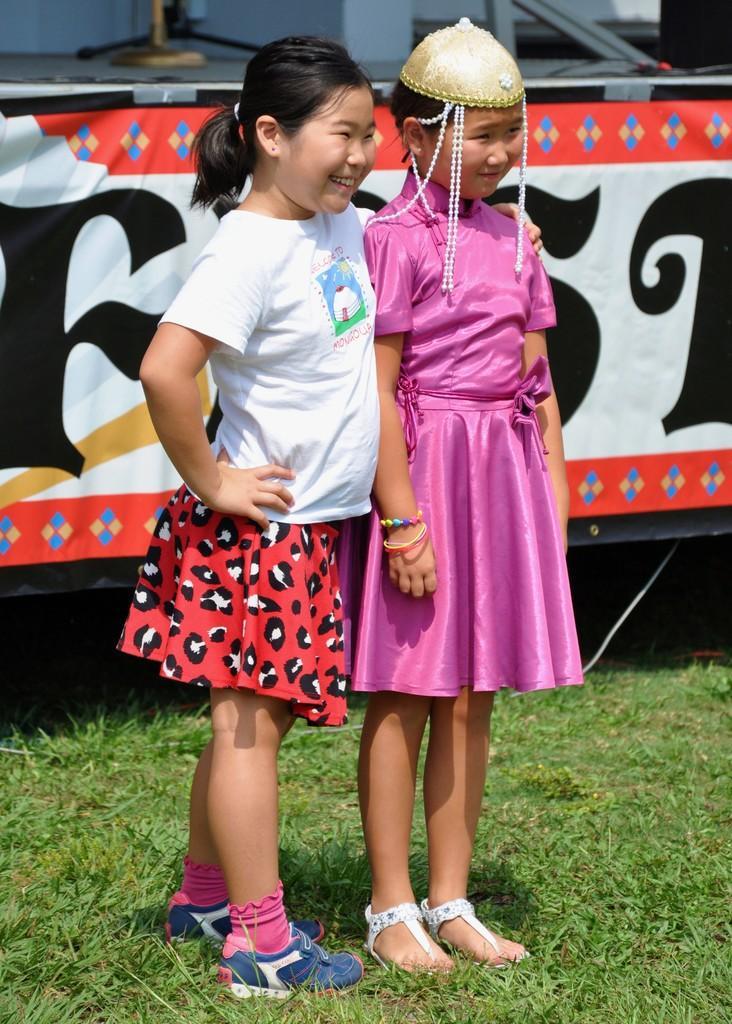Describe this image in one or two sentences. In this image we can see two girls standing on the grass. In the background we can see an advertisement. 